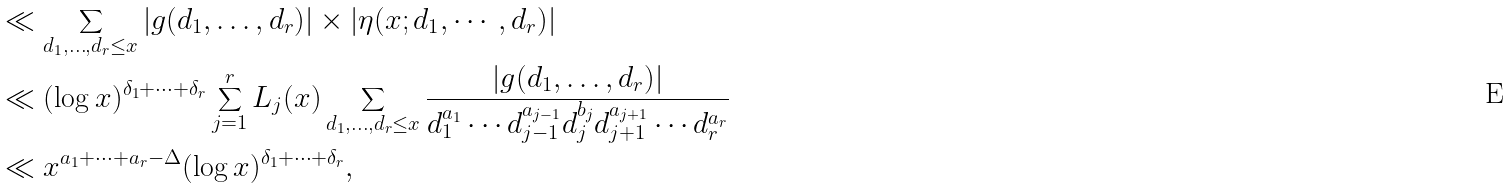Convert formula to latex. <formula><loc_0><loc_0><loc_500><loc_500>& \ll \sum _ { d _ { 1 } , \dots , d _ { r } \leq x } | g ( d _ { 1 } , \dots , d _ { r } ) | \times | \eta ( x ; d _ { 1 } , \cdots , d _ { r } ) | \\ & \ll ( \log x ) ^ { \delta _ { 1 } + \cdots + \delta _ { r } } \sum _ { j = 1 } ^ { r } L _ { j } ( x ) \sum _ { d _ { 1 } , \dots , d _ { r } \leq x } \frac { | g ( d _ { 1 } , \dots , d _ { r } ) | } { d _ { 1 } ^ { a _ { 1 } } \cdots d _ { j - 1 } ^ { a _ { j - 1 } } d _ { j } ^ { b _ { j } } d _ { j + 1 } ^ { a _ { j + 1 } } \cdots d _ { r } ^ { a _ { r } } } \\ & \ll x ^ { a _ { 1 } + \cdots + a _ { r } - \Delta } ( \log x ) ^ { \delta _ { 1 } + \cdots + \delta _ { r } } ,</formula> 